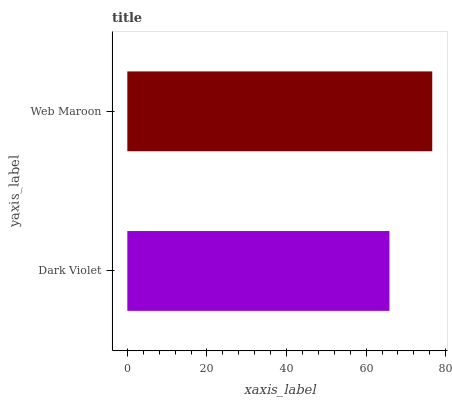Is Dark Violet the minimum?
Answer yes or no. Yes. Is Web Maroon the maximum?
Answer yes or no. Yes. Is Web Maroon the minimum?
Answer yes or no. No. Is Web Maroon greater than Dark Violet?
Answer yes or no. Yes. Is Dark Violet less than Web Maroon?
Answer yes or no. Yes. Is Dark Violet greater than Web Maroon?
Answer yes or no. No. Is Web Maroon less than Dark Violet?
Answer yes or no. No. Is Web Maroon the high median?
Answer yes or no. Yes. Is Dark Violet the low median?
Answer yes or no. Yes. Is Dark Violet the high median?
Answer yes or no. No. Is Web Maroon the low median?
Answer yes or no. No. 